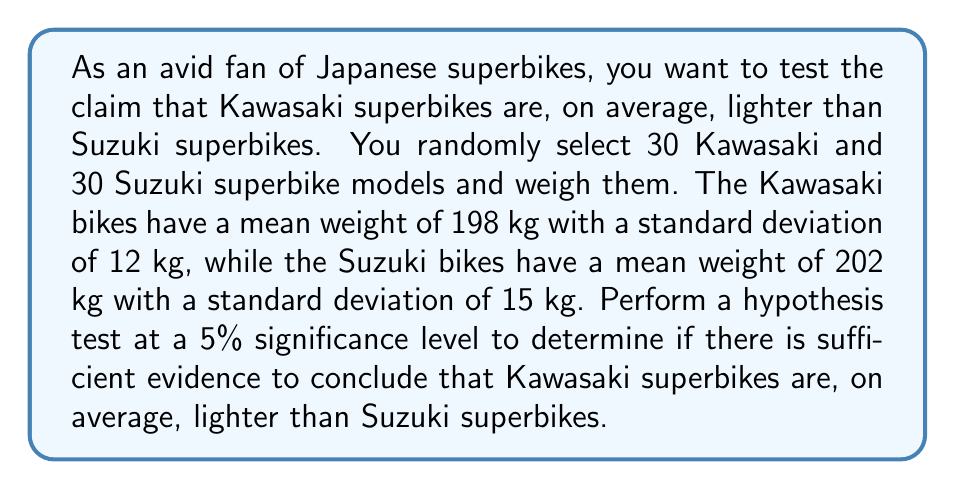Teach me how to tackle this problem. To perform this hypothesis test, we'll follow these steps:

1) Define the hypotheses:
   $H_0: \mu_K \geq \mu_S$ (Kawasaki bikes are not lighter on average)
   $H_a: \mu_K < \mu_S$ (Kawasaki bikes are lighter on average)

2) Choose the significance level: $\alpha = 0.05$

3) Calculate the test statistic:
   We'll use a two-sample t-test, as we're comparing means of two independent groups.
   
   The formula for the t-statistic is:
   
   $$t = \frac{\bar{x}_K - \bar{x}_S}{\sqrt{\frac{s_K^2}{n_K} + \frac{s_S^2}{n_S}}}$$

   Where:
   $\bar{x}_K = 198$ (mean weight of Kawasaki bikes)
   $\bar{x}_S = 202$ (mean weight of Suzuki bikes)
   $s_K = 12$ (standard deviation of Kawasaki bikes)
   $s_S = 15$ (standard deviation of Suzuki bikes)
   $n_K = n_S = 30$ (sample sizes)

   Plugging in the values:

   $$t = \frac{198 - 202}{\sqrt{\frac{12^2}{30} + \frac{15^2}{30}}} = \frac{-4}{\sqrt{4.8 + 7.5}} = \frac{-4}{\sqrt{12.3}} \approx -1.14$$

4) Calculate the degrees of freedom:
   For unequal variances, we use the Welch–Satterthwaite equation:
   
   $$df = \frac{(\frac{s_K^2}{n_K} + \frac{s_S^2}{n_S})^2}{\frac{(s_K^2/n_K)^2}{n_K-1} + \frac{(s_S^2/n_S)^2}{n_S-1}}$$

   Plugging in the values:
   
   $$df = \frac{(4.8 + 7.5)^2}{\frac{4.8^2}{29} + \frac{7.5^2}{29}} \approx 55.65$$

   We'll round down to 55 degrees of freedom.

5) Find the critical value:
   For a one-tailed test with $\alpha = 0.05$ and $df = 55$, the critical t-value is approximately -1.673.

6) Make a decision:
   Since our test statistic (-1.14) is greater than the critical value (-1.673), we fail to reject the null hypothesis.

7) State the conclusion:
   There is not sufficient evidence to conclude that Kawasaki superbikes are, on average, lighter than Suzuki superbikes at the 5% significance level.
Answer: Fail to reject the null hypothesis. There is not sufficient evidence to conclude that Kawasaki superbikes are, on average, lighter than Suzuki superbikes at the 5% significance level. 